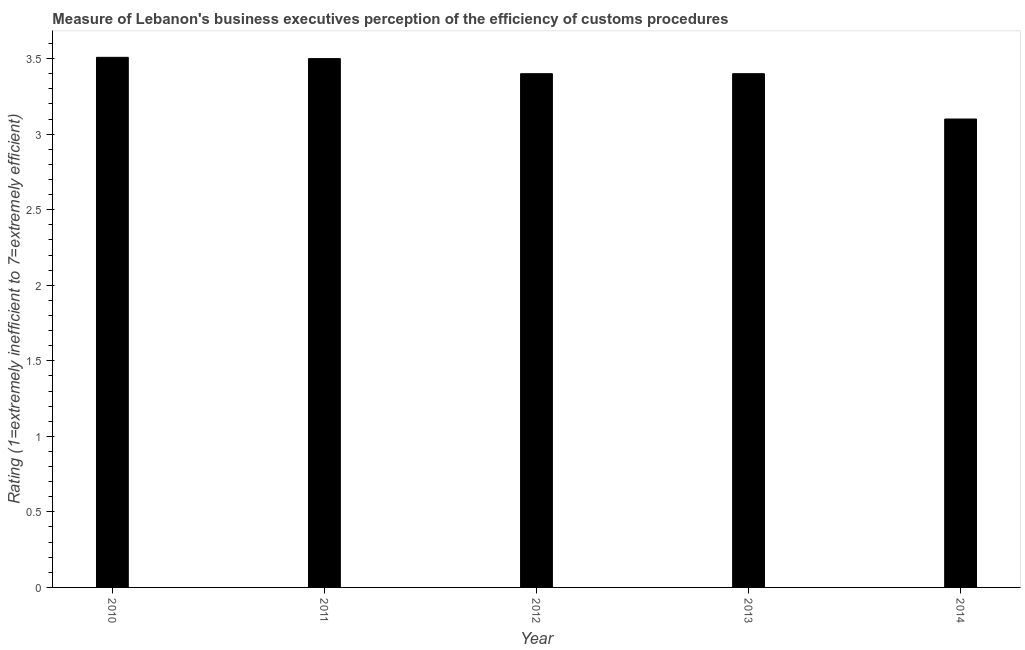Does the graph contain any zero values?
Make the answer very short. No. What is the title of the graph?
Offer a terse response. Measure of Lebanon's business executives perception of the efficiency of customs procedures. What is the label or title of the X-axis?
Your response must be concise. Year. What is the label or title of the Y-axis?
Your answer should be compact. Rating (1=extremely inefficient to 7=extremely efficient). What is the rating measuring burden of customs procedure in 2011?
Offer a very short reply. 3.5. Across all years, what is the maximum rating measuring burden of customs procedure?
Offer a very short reply. 3.51. Across all years, what is the minimum rating measuring burden of customs procedure?
Your answer should be very brief. 3.1. In which year was the rating measuring burden of customs procedure minimum?
Your response must be concise. 2014. What is the sum of the rating measuring burden of customs procedure?
Your response must be concise. 16.91. What is the difference between the rating measuring burden of customs procedure in 2013 and 2014?
Provide a short and direct response. 0.3. What is the average rating measuring burden of customs procedure per year?
Offer a terse response. 3.38. In how many years, is the rating measuring burden of customs procedure greater than 2 ?
Make the answer very short. 5. What is the ratio of the rating measuring burden of customs procedure in 2011 to that in 2014?
Offer a terse response. 1.13. What is the difference between the highest and the second highest rating measuring burden of customs procedure?
Ensure brevity in your answer.  0.01. What is the difference between the highest and the lowest rating measuring burden of customs procedure?
Your answer should be compact. 0.41. In how many years, is the rating measuring burden of customs procedure greater than the average rating measuring burden of customs procedure taken over all years?
Provide a succinct answer. 4. Are all the bars in the graph horizontal?
Your response must be concise. No. How many years are there in the graph?
Keep it short and to the point. 5. What is the difference between two consecutive major ticks on the Y-axis?
Offer a very short reply. 0.5. Are the values on the major ticks of Y-axis written in scientific E-notation?
Provide a succinct answer. No. What is the Rating (1=extremely inefficient to 7=extremely efficient) of 2010?
Offer a terse response. 3.51. What is the Rating (1=extremely inefficient to 7=extremely efficient) of 2011?
Provide a succinct answer. 3.5. What is the Rating (1=extremely inefficient to 7=extremely efficient) in 2012?
Provide a short and direct response. 3.4. What is the Rating (1=extremely inefficient to 7=extremely efficient) in 2013?
Your answer should be compact. 3.4. What is the difference between the Rating (1=extremely inefficient to 7=extremely efficient) in 2010 and 2011?
Give a very brief answer. 0.01. What is the difference between the Rating (1=extremely inefficient to 7=extremely efficient) in 2010 and 2012?
Provide a succinct answer. 0.11. What is the difference between the Rating (1=extremely inefficient to 7=extremely efficient) in 2010 and 2013?
Provide a short and direct response. 0.11. What is the difference between the Rating (1=extremely inefficient to 7=extremely efficient) in 2010 and 2014?
Provide a succinct answer. 0.41. What is the difference between the Rating (1=extremely inefficient to 7=extremely efficient) in 2012 and 2014?
Ensure brevity in your answer.  0.3. What is the ratio of the Rating (1=extremely inefficient to 7=extremely efficient) in 2010 to that in 2012?
Give a very brief answer. 1.03. What is the ratio of the Rating (1=extremely inefficient to 7=extremely efficient) in 2010 to that in 2013?
Offer a terse response. 1.03. What is the ratio of the Rating (1=extremely inefficient to 7=extremely efficient) in 2010 to that in 2014?
Give a very brief answer. 1.13. What is the ratio of the Rating (1=extremely inefficient to 7=extremely efficient) in 2011 to that in 2014?
Provide a short and direct response. 1.13. What is the ratio of the Rating (1=extremely inefficient to 7=extremely efficient) in 2012 to that in 2013?
Provide a succinct answer. 1. What is the ratio of the Rating (1=extremely inefficient to 7=extremely efficient) in 2012 to that in 2014?
Ensure brevity in your answer.  1.1. What is the ratio of the Rating (1=extremely inefficient to 7=extremely efficient) in 2013 to that in 2014?
Your answer should be very brief. 1.1. 